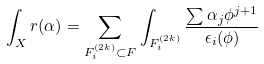<formula> <loc_0><loc_0><loc_500><loc_500>\int _ { X } r ( \alpha ) = \sum _ { F _ { i } ^ { ( 2 k ) } \subset F } \int _ { F _ { i } ^ { ( 2 k ) } } \frac { \sum \alpha _ { j } \phi ^ { j + 1 } } { \epsilon _ { i } ( \phi ) }</formula> 